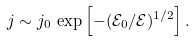<formula> <loc_0><loc_0><loc_500><loc_500>j \sim j _ { 0 } \, \exp \left [ - ( \mathcal { E } _ { 0 } / \mathcal { E } ) ^ { 1 / 2 } \right ] .</formula> 